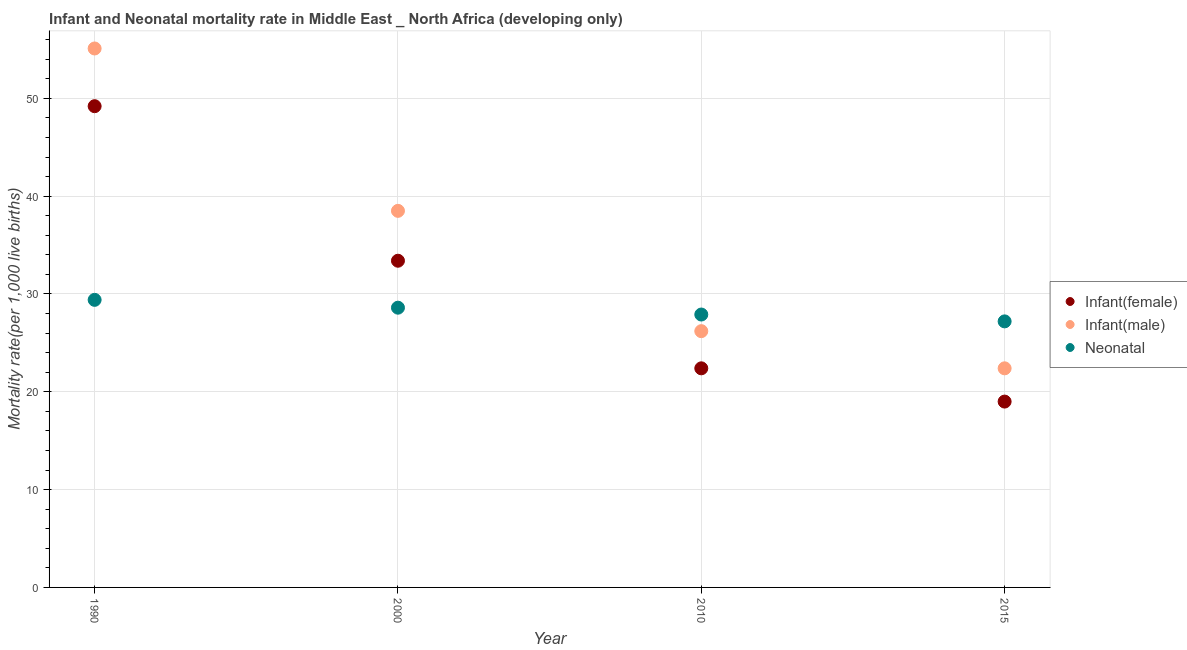What is the infant mortality rate(male) in 2015?
Provide a succinct answer. 22.4. Across all years, what is the maximum infant mortality rate(male)?
Provide a succinct answer. 55.1. Across all years, what is the minimum neonatal mortality rate?
Provide a succinct answer. 27.2. In which year was the infant mortality rate(female) minimum?
Make the answer very short. 2015. What is the total neonatal mortality rate in the graph?
Your answer should be compact. 113.1. What is the difference between the infant mortality rate(female) in 1990 and that in 2010?
Ensure brevity in your answer.  26.8. What is the difference between the neonatal mortality rate in 2010 and the infant mortality rate(female) in 2000?
Offer a terse response. -5.5. What is the average neonatal mortality rate per year?
Your answer should be very brief. 28.28. In the year 2010, what is the difference between the infant mortality rate(male) and infant mortality rate(female)?
Your answer should be compact. 3.8. What is the ratio of the neonatal mortality rate in 2010 to that in 2015?
Provide a short and direct response. 1.03. Is the infant mortality rate(male) in 1990 less than that in 2000?
Provide a short and direct response. No. Is the difference between the infant mortality rate(female) in 1990 and 2000 greater than the difference between the neonatal mortality rate in 1990 and 2000?
Give a very brief answer. Yes. What is the difference between the highest and the second highest neonatal mortality rate?
Provide a succinct answer. 0.8. What is the difference between the highest and the lowest infant mortality rate(female)?
Keep it short and to the point. 30.2. In how many years, is the infant mortality rate(male) greater than the average infant mortality rate(male) taken over all years?
Keep it short and to the point. 2. Is it the case that in every year, the sum of the infant mortality rate(female) and infant mortality rate(male) is greater than the neonatal mortality rate?
Give a very brief answer. Yes. Does the neonatal mortality rate monotonically increase over the years?
Provide a succinct answer. No. How many years are there in the graph?
Your answer should be very brief. 4. Does the graph contain grids?
Keep it short and to the point. Yes. How are the legend labels stacked?
Your response must be concise. Vertical. What is the title of the graph?
Offer a terse response. Infant and Neonatal mortality rate in Middle East _ North Africa (developing only). What is the label or title of the X-axis?
Provide a succinct answer. Year. What is the label or title of the Y-axis?
Offer a terse response. Mortality rate(per 1,0 live births). What is the Mortality rate(per 1,000 live births) in Infant(female) in 1990?
Provide a short and direct response. 49.2. What is the Mortality rate(per 1,000 live births) of Infant(male) in 1990?
Give a very brief answer. 55.1. What is the Mortality rate(per 1,000 live births) in Neonatal  in 1990?
Provide a succinct answer. 29.4. What is the Mortality rate(per 1,000 live births) in Infant(female) in 2000?
Keep it short and to the point. 33.4. What is the Mortality rate(per 1,000 live births) in Infant(male) in 2000?
Your answer should be very brief. 38.5. What is the Mortality rate(per 1,000 live births) of Neonatal  in 2000?
Your response must be concise. 28.6. What is the Mortality rate(per 1,000 live births) in Infant(female) in 2010?
Your answer should be compact. 22.4. What is the Mortality rate(per 1,000 live births) of Infant(male) in 2010?
Give a very brief answer. 26.2. What is the Mortality rate(per 1,000 live births) of Neonatal  in 2010?
Keep it short and to the point. 27.9. What is the Mortality rate(per 1,000 live births) of Infant(male) in 2015?
Keep it short and to the point. 22.4. What is the Mortality rate(per 1,000 live births) in Neonatal  in 2015?
Your answer should be compact. 27.2. Across all years, what is the maximum Mortality rate(per 1,000 live births) of Infant(female)?
Ensure brevity in your answer.  49.2. Across all years, what is the maximum Mortality rate(per 1,000 live births) of Infant(male)?
Provide a short and direct response. 55.1. Across all years, what is the maximum Mortality rate(per 1,000 live births) in Neonatal ?
Provide a short and direct response. 29.4. Across all years, what is the minimum Mortality rate(per 1,000 live births) in Infant(female)?
Your answer should be compact. 19. Across all years, what is the minimum Mortality rate(per 1,000 live births) in Infant(male)?
Give a very brief answer. 22.4. Across all years, what is the minimum Mortality rate(per 1,000 live births) of Neonatal ?
Keep it short and to the point. 27.2. What is the total Mortality rate(per 1,000 live births) of Infant(female) in the graph?
Provide a succinct answer. 124. What is the total Mortality rate(per 1,000 live births) in Infant(male) in the graph?
Provide a succinct answer. 142.2. What is the total Mortality rate(per 1,000 live births) in Neonatal  in the graph?
Your answer should be very brief. 113.1. What is the difference between the Mortality rate(per 1,000 live births) of Infant(female) in 1990 and that in 2000?
Keep it short and to the point. 15.8. What is the difference between the Mortality rate(per 1,000 live births) in Infant(female) in 1990 and that in 2010?
Provide a succinct answer. 26.8. What is the difference between the Mortality rate(per 1,000 live births) of Infant(male) in 1990 and that in 2010?
Give a very brief answer. 28.9. What is the difference between the Mortality rate(per 1,000 live births) in Infant(female) in 1990 and that in 2015?
Provide a succinct answer. 30.2. What is the difference between the Mortality rate(per 1,000 live births) of Infant(male) in 1990 and that in 2015?
Offer a very short reply. 32.7. What is the difference between the Mortality rate(per 1,000 live births) of Infant(male) in 2000 and that in 2010?
Keep it short and to the point. 12.3. What is the difference between the Mortality rate(per 1,000 live births) in Infant(female) in 2000 and that in 2015?
Offer a terse response. 14.4. What is the difference between the Mortality rate(per 1,000 live births) in Infant(male) in 2000 and that in 2015?
Make the answer very short. 16.1. What is the difference between the Mortality rate(per 1,000 live births) of Infant(female) in 2010 and that in 2015?
Your response must be concise. 3.4. What is the difference between the Mortality rate(per 1,000 live births) of Neonatal  in 2010 and that in 2015?
Your answer should be compact. 0.7. What is the difference between the Mortality rate(per 1,000 live births) of Infant(female) in 1990 and the Mortality rate(per 1,000 live births) of Neonatal  in 2000?
Your response must be concise. 20.6. What is the difference between the Mortality rate(per 1,000 live births) in Infant(female) in 1990 and the Mortality rate(per 1,000 live births) in Infant(male) in 2010?
Offer a very short reply. 23. What is the difference between the Mortality rate(per 1,000 live births) in Infant(female) in 1990 and the Mortality rate(per 1,000 live births) in Neonatal  in 2010?
Make the answer very short. 21.3. What is the difference between the Mortality rate(per 1,000 live births) in Infant(male) in 1990 and the Mortality rate(per 1,000 live births) in Neonatal  in 2010?
Provide a short and direct response. 27.2. What is the difference between the Mortality rate(per 1,000 live births) in Infant(female) in 1990 and the Mortality rate(per 1,000 live births) in Infant(male) in 2015?
Offer a terse response. 26.8. What is the difference between the Mortality rate(per 1,000 live births) of Infant(female) in 1990 and the Mortality rate(per 1,000 live births) of Neonatal  in 2015?
Ensure brevity in your answer.  22. What is the difference between the Mortality rate(per 1,000 live births) in Infant(male) in 1990 and the Mortality rate(per 1,000 live births) in Neonatal  in 2015?
Give a very brief answer. 27.9. What is the difference between the Mortality rate(per 1,000 live births) in Infant(female) in 2000 and the Mortality rate(per 1,000 live births) in Neonatal  in 2015?
Your answer should be very brief. 6.2. What is the difference between the Mortality rate(per 1,000 live births) of Infant(female) in 2010 and the Mortality rate(per 1,000 live births) of Infant(male) in 2015?
Provide a succinct answer. 0. What is the difference between the Mortality rate(per 1,000 live births) of Infant(female) in 2010 and the Mortality rate(per 1,000 live births) of Neonatal  in 2015?
Keep it short and to the point. -4.8. What is the difference between the Mortality rate(per 1,000 live births) in Infant(male) in 2010 and the Mortality rate(per 1,000 live births) in Neonatal  in 2015?
Ensure brevity in your answer.  -1. What is the average Mortality rate(per 1,000 live births) of Infant(male) per year?
Keep it short and to the point. 35.55. What is the average Mortality rate(per 1,000 live births) in Neonatal  per year?
Provide a short and direct response. 28.27. In the year 1990, what is the difference between the Mortality rate(per 1,000 live births) in Infant(female) and Mortality rate(per 1,000 live births) in Infant(male)?
Your answer should be very brief. -5.9. In the year 1990, what is the difference between the Mortality rate(per 1,000 live births) of Infant(female) and Mortality rate(per 1,000 live births) of Neonatal ?
Provide a succinct answer. 19.8. In the year 1990, what is the difference between the Mortality rate(per 1,000 live births) in Infant(male) and Mortality rate(per 1,000 live births) in Neonatal ?
Ensure brevity in your answer.  25.7. In the year 2000, what is the difference between the Mortality rate(per 1,000 live births) of Infant(female) and Mortality rate(per 1,000 live births) of Infant(male)?
Offer a terse response. -5.1. In the year 2000, what is the difference between the Mortality rate(per 1,000 live births) of Infant(male) and Mortality rate(per 1,000 live births) of Neonatal ?
Your response must be concise. 9.9. In the year 2010, what is the difference between the Mortality rate(per 1,000 live births) of Infant(male) and Mortality rate(per 1,000 live births) of Neonatal ?
Make the answer very short. -1.7. In the year 2015, what is the difference between the Mortality rate(per 1,000 live births) of Infant(female) and Mortality rate(per 1,000 live births) of Neonatal ?
Your answer should be very brief. -8.2. In the year 2015, what is the difference between the Mortality rate(per 1,000 live births) in Infant(male) and Mortality rate(per 1,000 live births) in Neonatal ?
Give a very brief answer. -4.8. What is the ratio of the Mortality rate(per 1,000 live births) of Infant(female) in 1990 to that in 2000?
Offer a terse response. 1.47. What is the ratio of the Mortality rate(per 1,000 live births) of Infant(male) in 1990 to that in 2000?
Your answer should be very brief. 1.43. What is the ratio of the Mortality rate(per 1,000 live births) in Neonatal  in 1990 to that in 2000?
Make the answer very short. 1.03. What is the ratio of the Mortality rate(per 1,000 live births) in Infant(female) in 1990 to that in 2010?
Give a very brief answer. 2.2. What is the ratio of the Mortality rate(per 1,000 live births) of Infant(male) in 1990 to that in 2010?
Your answer should be very brief. 2.1. What is the ratio of the Mortality rate(per 1,000 live births) of Neonatal  in 1990 to that in 2010?
Keep it short and to the point. 1.05. What is the ratio of the Mortality rate(per 1,000 live births) in Infant(female) in 1990 to that in 2015?
Make the answer very short. 2.59. What is the ratio of the Mortality rate(per 1,000 live births) in Infant(male) in 1990 to that in 2015?
Give a very brief answer. 2.46. What is the ratio of the Mortality rate(per 1,000 live births) in Neonatal  in 1990 to that in 2015?
Provide a short and direct response. 1.08. What is the ratio of the Mortality rate(per 1,000 live births) in Infant(female) in 2000 to that in 2010?
Provide a succinct answer. 1.49. What is the ratio of the Mortality rate(per 1,000 live births) in Infant(male) in 2000 to that in 2010?
Give a very brief answer. 1.47. What is the ratio of the Mortality rate(per 1,000 live births) of Neonatal  in 2000 to that in 2010?
Provide a short and direct response. 1.03. What is the ratio of the Mortality rate(per 1,000 live births) in Infant(female) in 2000 to that in 2015?
Your response must be concise. 1.76. What is the ratio of the Mortality rate(per 1,000 live births) of Infant(male) in 2000 to that in 2015?
Ensure brevity in your answer.  1.72. What is the ratio of the Mortality rate(per 1,000 live births) in Neonatal  in 2000 to that in 2015?
Make the answer very short. 1.05. What is the ratio of the Mortality rate(per 1,000 live births) in Infant(female) in 2010 to that in 2015?
Provide a succinct answer. 1.18. What is the ratio of the Mortality rate(per 1,000 live births) in Infant(male) in 2010 to that in 2015?
Your answer should be very brief. 1.17. What is the ratio of the Mortality rate(per 1,000 live births) in Neonatal  in 2010 to that in 2015?
Offer a very short reply. 1.03. What is the difference between the highest and the second highest Mortality rate(per 1,000 live births) of Infant(female)?
Your answer should be very brief. 15.8. What is the difference between the highest and the second highest Mortality rate(per 1,000 live births) in Infant(male)?
Provide a short and direct response. 16.6. What is the difference between the highest and the second highest Mortality rate(per 1,000 live births) of Neonatal ?
Your answer should be very brief. 0.8. What is the difference between the highest and the lowest Mortality rate(per 1,000 live births) in Infant(female)?
Your answer should be very brief. 30.2. What is the difference between the highest and the lowest Mortality rate(per 1,000 live births) in Infant(male)?
Ensure brevity in your answer.  32.7. What is the difference between the highest and the lowest Mortality rate(per 1,000 live births) of Neonatal ?
Your answer should be very brief. 2.2. 